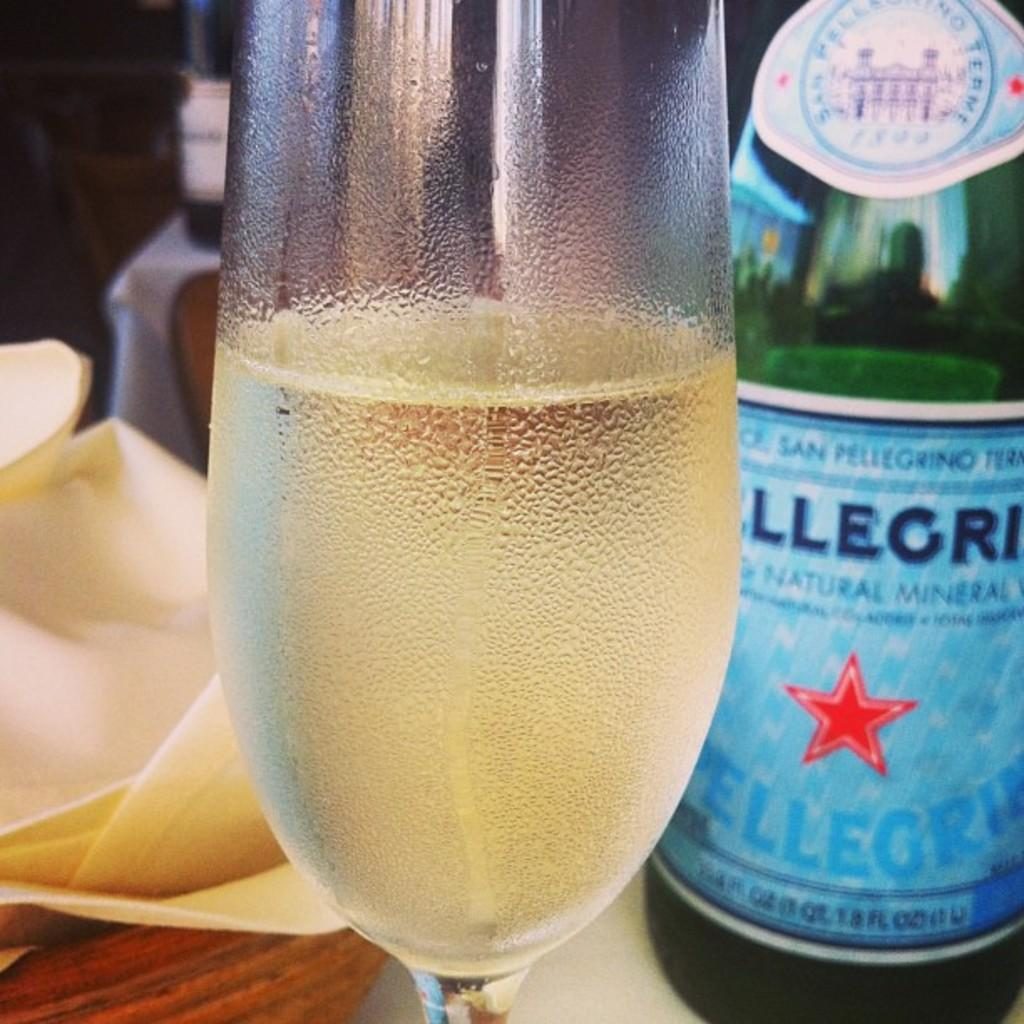What type of beverage is featured in the image? There is a wine bottle and a glass filled with wine in the image. How many wine bottles are visible in the image? There are two wine bottles visible in the image. Where are the wine bottles located in the image? One wine bottle is in the glass, and another is on the table in the image. Can you see a kitty offering a hill in the image? No, there is no kitty or hill present in the image. 